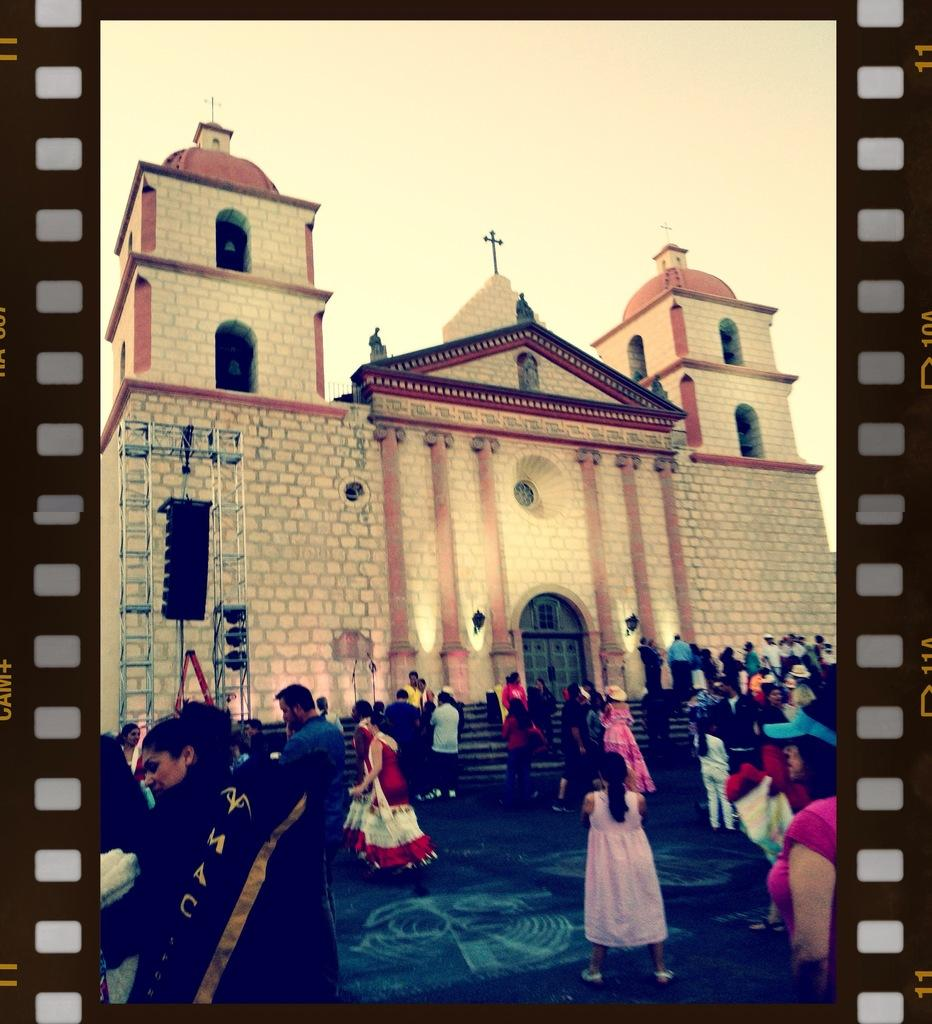What type of structure is visible in the image? There is a building in the image. What features can be seen on the building? The building has windows, doors, and steps. Can you describe the people in the image? There is a group of people standing on the ground in the image. What type of power is being generated by the building in the image? There is no indication in the image that the building is generating any power. Is there a birthday celebration happening in the image? There is no indication in the image of a birthday celebration or any related activities. 